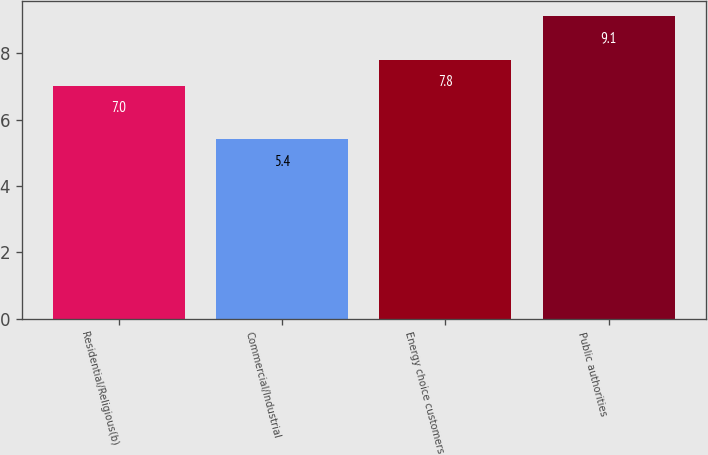Convert chart to OTSL. <chart><loc_0><loc_0><loc_500><loc_500><bar_chart><fcel>Residential/Religious(b)<fcel>Commercial/Industrial<fcel>Energy choice customers<fcel>Public authorities<nl><fcel>7<fcel>5.4<fcel>7.8<fcel>9.1<nl></chart> 